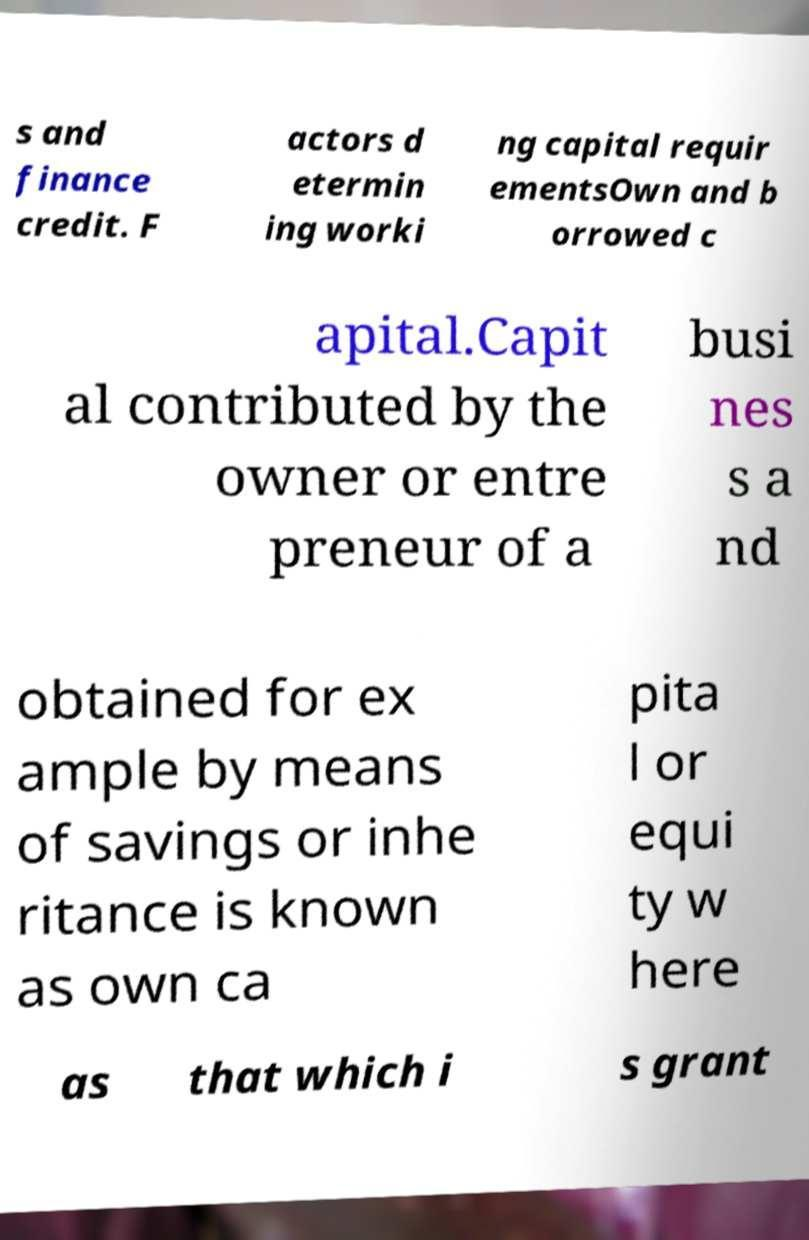I need the written content from this picture converted into text. Can you do that? s and finance credit. F actors d etermin ing worki ng capital requir ementsOwn and b orrowed c apital.Capit al contributed by the owner or entre preneur of a busi nes s a nd obtained for ex ample by means of savings or inhe ritance is known as own ca pita l or equi ty w here as that which i s grant 